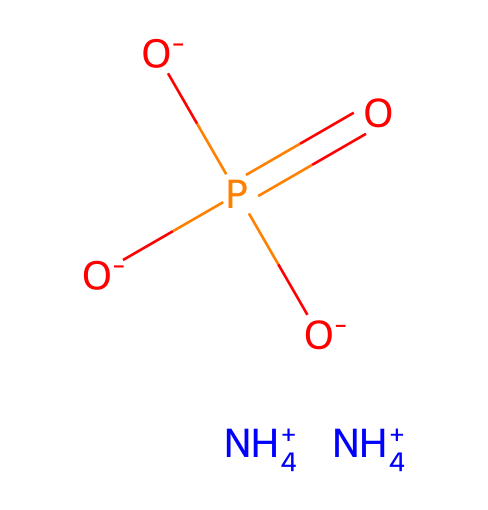How many ammonium ions are present in this structure? The chemical structure contains two NH4+ ions, as indicated by the two NH4+ components in the SMILES representation.
Answer: two What type of bond links the phosphorus to the oxygen atoms? The phosphorus atom in the structure forms single and double bonds with oxygen; specifically, one double bond (P=O) and three single bonds (P-O).
Answer: single and double What is the charge of the phosphate group in this compound? The phosphate group depicted here has a total charge of -3, as indicated by three negatively charged oxygen atoms (O-) connected to the phosphorus.
Answer: -3 How many oxygen atoms are bonded to phosphorus? In this structure, there are four oxygen atoms directly bonded to the phosphorus atom; one is involved in a double bond, and three are involved in single bonds.
Answer: four What type of chemical is this molecule classified as? This molecule is classified as a phosphate fertilizer, which consists of ammonium and phosphate ions commonly used in agriculture.
Answer: phosphate fertilizer What is the total number of atoms in this chemical structure? To find the total number of atoms, count the individual elements: 2 nitrogen, 4 hydrogen, 1 phosphorus, and 4 oxygen, giving a total of 11 atoms.
Answer: eleven 